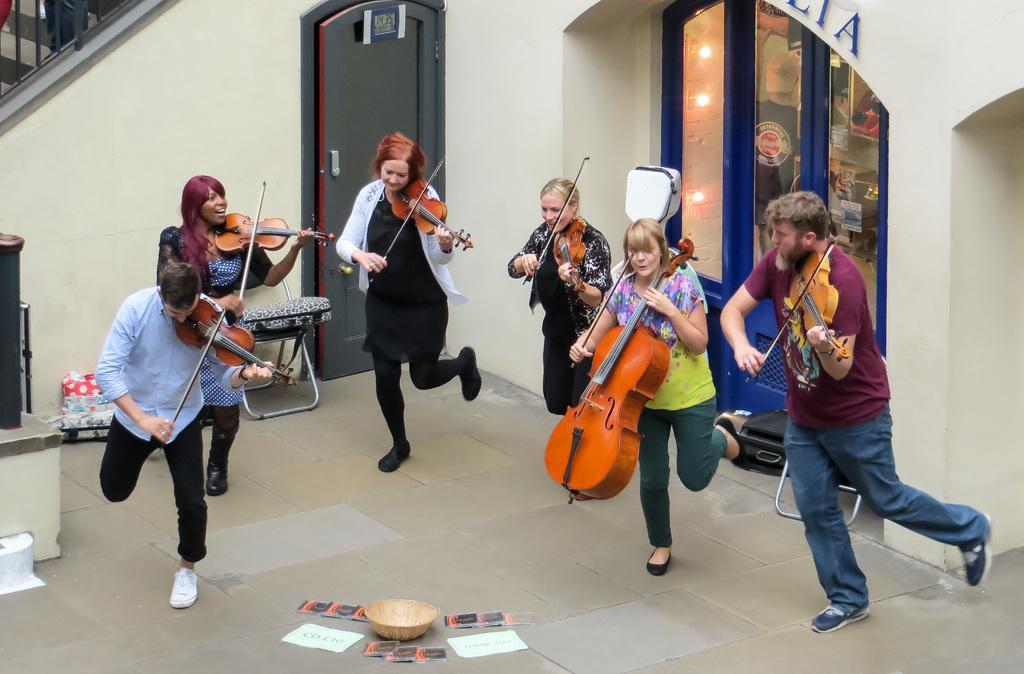How would you summarize this image in a sentence or two? There are six persons standing and holding violins and playing. In the center there is a basket. In the back there is a wall, door and a staircase is on the left corner. 